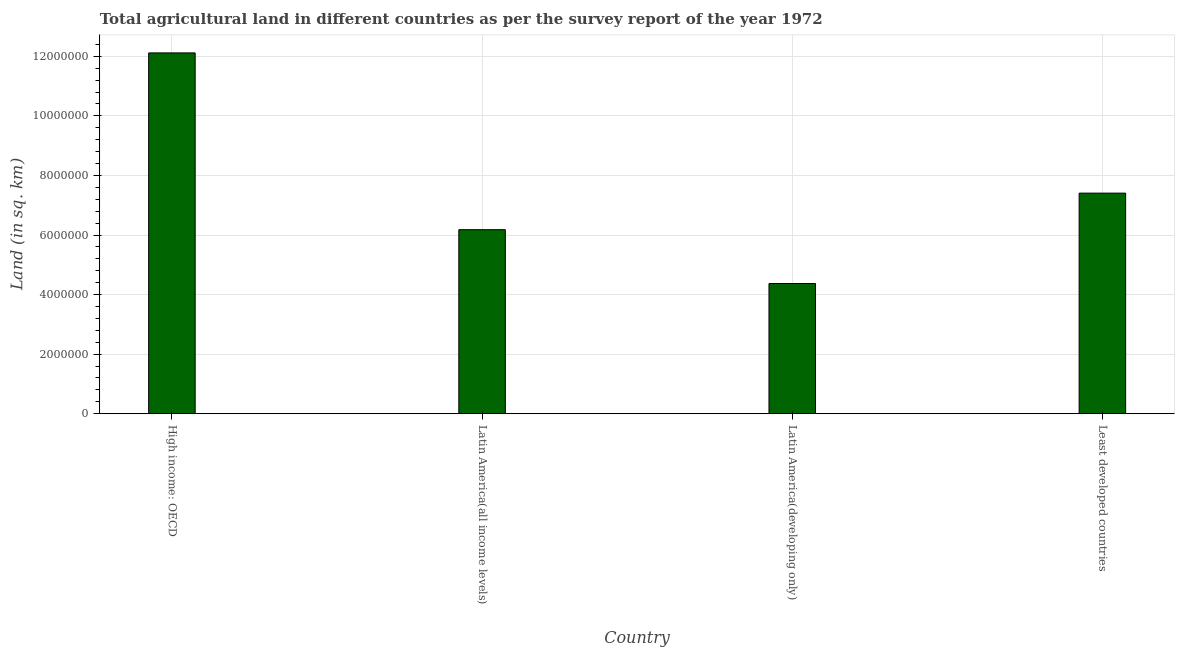Does the graph contain any zero values?
Your answer should be very brief. No. What is the title of the graph?
Keep it short and to the point. Total agricultural land in different countries as per the survey report of the year 1972. What is the label or title of the Y-axis?
Provide a succinct answer. Land (in sq. km). What is the agricultural land in Latin America(developing only)?
Keep it short and to the point. 4.37e+06. Across all countries, what is the maximum agricultural land?
Make the answer very short. 1.21e+07. Across all countries, what is the minimum agricultural land?
Provide a short and direct response. 4.37e+06. In which country was the agricultural land maximum?
Provide a succinct answer. High income: OECD. In which country was the agricultural land minimum?
Your response must be concise. Latin America(developing only). What is the sum of the agricultural land?
Offer a terse response. 3.01e+07. What is the difference between the agricultural land in Latin America(all income levels) and Latin America(developing only)?
Provide a short and direct response. 1.81e+06. What is the average agricultural land per country?
Give a very brief answer. 7.52e+06. What is the median agricultural land?
Offer a terse response. 6.79e+06. In how many countries, is the agricultural land greater than 6800000 sq. km?
Ensure brevity in your answer.  2. What is the ratio of the agricultural land in High income: OECD to that in Latin America(developing only)?
Your response must be concise. 2.77. Is the difference between the agricultural land in Latin America(developing only) and Least developed countries greater than the difference between any two countries?
Keep it short and to the point. No. What is the difference between the highest and the second highest agricultural land?
Make the answer very short. 4.71e+06. Is the sum of the agricultural land in Latin America(all income levels) and Latin America(developing only) greater than the maximum agricultural land across all countries?
Offer a terse response. No. What is the difference between the highest and the lowest agricultural land?
Provide a succinct answer. 7.74e+06. In how many countries, is the agricultural land greater than the average agricultural land taken over all countries?
Give a very brief answer. 1. How many bars are there?
Provide a succinct answer. 4. Are the values on the major ticks of Y-axis written in scientific E-notation?
Your response must be concise. No. What is the Land (in sq. km) of High income: OECD?
Your response must be concise. 1.21e+07. What is the Land (in sq. km) of Latin America(all income levels)?
Your response must be concise. 6.18e+06. What is the Land (in sq. km) in Latin America(developing only)?
Offer a very short reply. 4.37e+06. What is the Land (in sq. km) in Least developed countries?
Give a very brief answer. 7.41e+06. What is the difference between the Land (in sq. km) in High income: OECD and Latin America(all income levels)?
Provide a succinct answer. 5.93e+06. What is the difference between the Land (in sq. km) in High income: OECD and Latin America(developing only)?
Make the answer very short. 7.74e+06. What is the difference between the Land (in sq. km) in High income: OECD and Least developed countries?
Your answer should be very brief. 4.71e+06. What is the difference between the Land (in sq. km) in Latin America(all income levels) and Latin America(developing only)?
Provide a succinct answer. 1.81e+06. What is the difference between the Land (in sq. km) in Latin America(all income levels) and Least developed countries?
Ensure brevity in your answer.  -1.23e+06. What is the difference between the Land (in sq. km) in Latin America(developing only) and Least developed countries?
Offer a terse response. -3.03e+06. What is the ratio of the Land (in sq. km) in High income: OECD to that in Latin America(all income levels)?
Your answer should be very brief. 1.96. What is the ratio of the Land (in sq. km) in High income: OECD to that in Latin America(developing only)?
Make the answer very short. 2.77. What is the ratio of the Land (in sq. km) in High income: OECD to that in Least developed countries?
Your response must be concise. 1.64. What is the ratio of the Land (in sq. km) in Latin America(all income levels) to that in Latin America(developing only)?
Offer a terse response. 1.41. What is the ratio of the Land (in sq. km) in Latin America(all income levels) to that in Least developed countries?
Your response must be concise. 0.83. What is the ratio of the Land (in sq. km) in Latin America(developing only) to that in Least developed countries?
Your response must be concise. 0.59. 